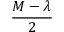<formula> <loc_0><loc_0><loc_500><loc_500>\frac { M - \lambda } { 2 }</formula> 